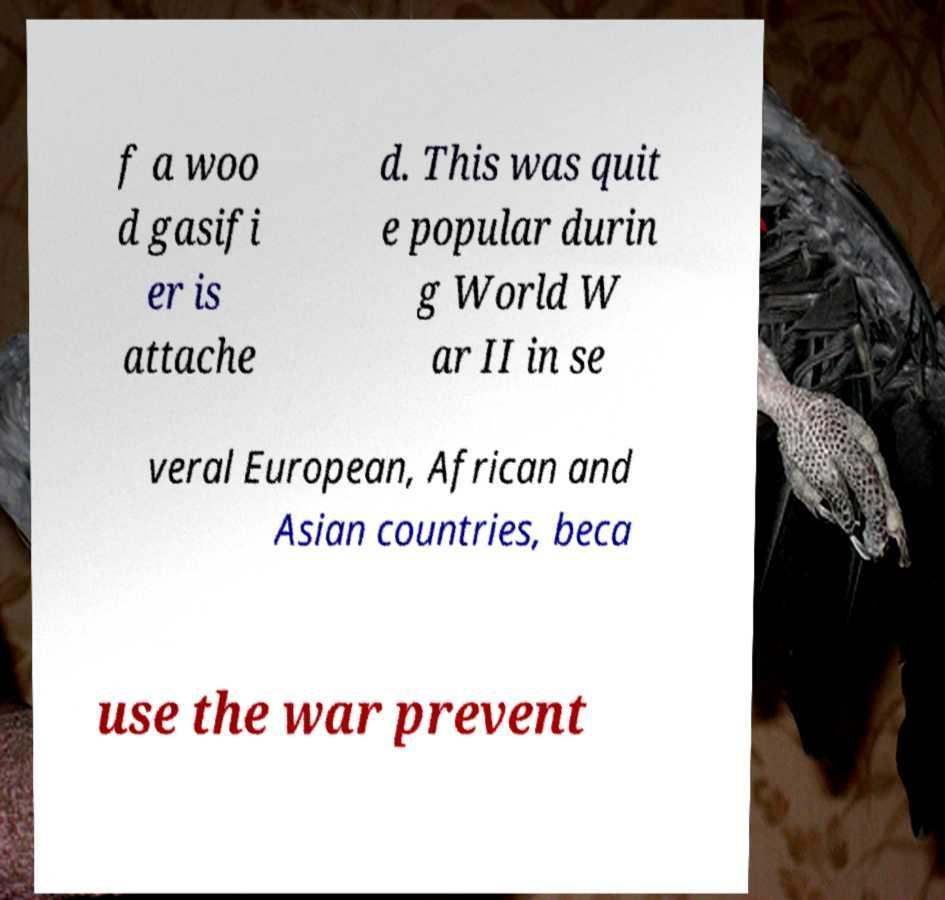I need the written content from this picture converted into text. Can you do that? f a woo d gasifi er is attache d. This was quit e popular durin g World W ar II in se veral European, African and Asian countries, beca use the war prevent 